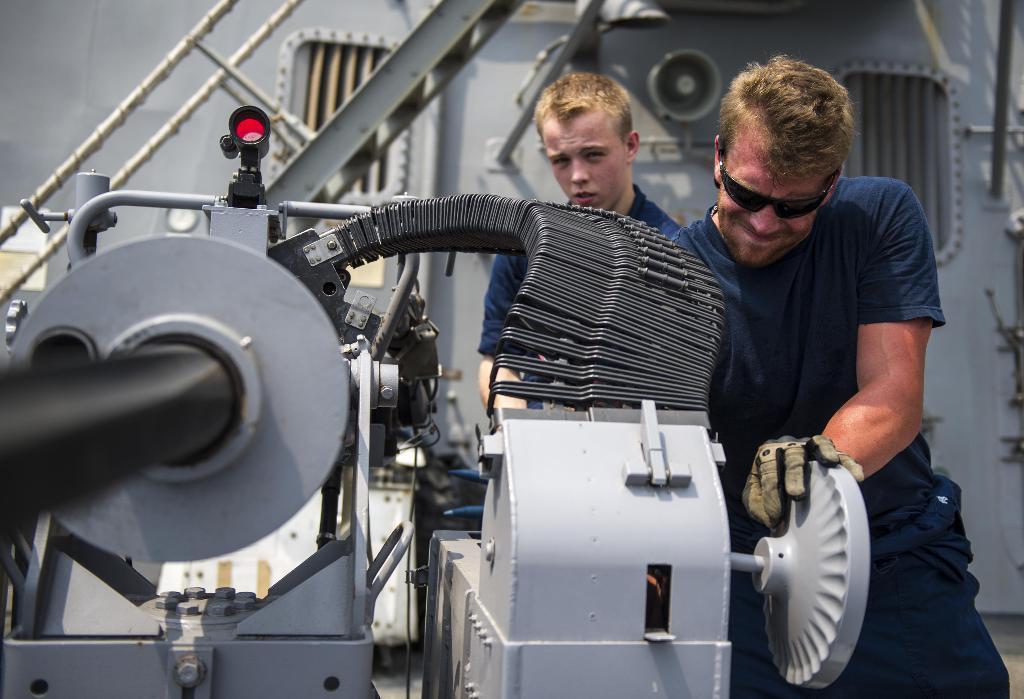Could you give a brief overview of what you see in this image? There are two men standing. This looks like a machine with pipes, wheel bolts and few other objects are attached to the machine. I think these are the stairs with the staircase holder. This looks like a window. 